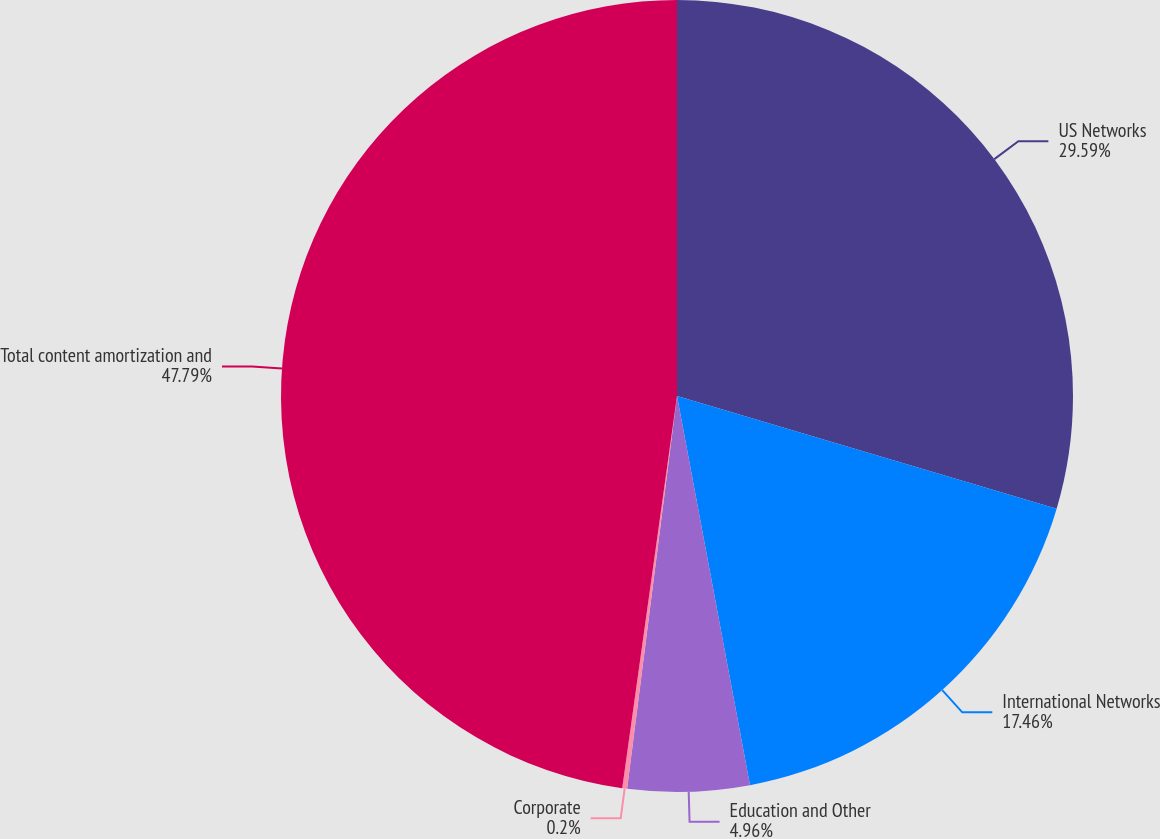<chart> <loc_0><loc_0><loc_500><loc_500><pie_chart><fcel>US Networks<fcel>International Networks<fcel>Education and Other<fcel>Corporate<fcel>Total content amortization and<nl><fcel>29.59%<fcel>17.46%<fcel>4.96%<fcel>0.2%<fcel>47.79%<nl></chart> 